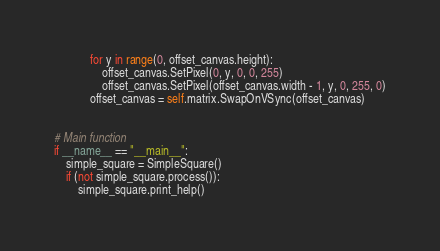Convert code to text. <code><loc_0><loc_0><loc_500><loc_500><_Python_>            for y in range(0, offset_canvas.height):
                offset_canvas.SetPixel(0, y, 0, 0, 255)
                offset_canvas.SetPixel(offset_canvas.width - 1, y, 0, 255, 0)
            offset_canvas = self.matrix.SwapOnVSync(offset_canvas)


# Main function
if __name__ == "__main__":
    simple_square = SimpleSquare()
    if (not simple_square.process()):
        simple_square.print_help()
</code> 